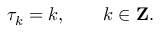<formula> <loc_0><loc_0><loc_500><loc_500>\tau _ { k } = k , \quad k \in { Z } .</formula> 